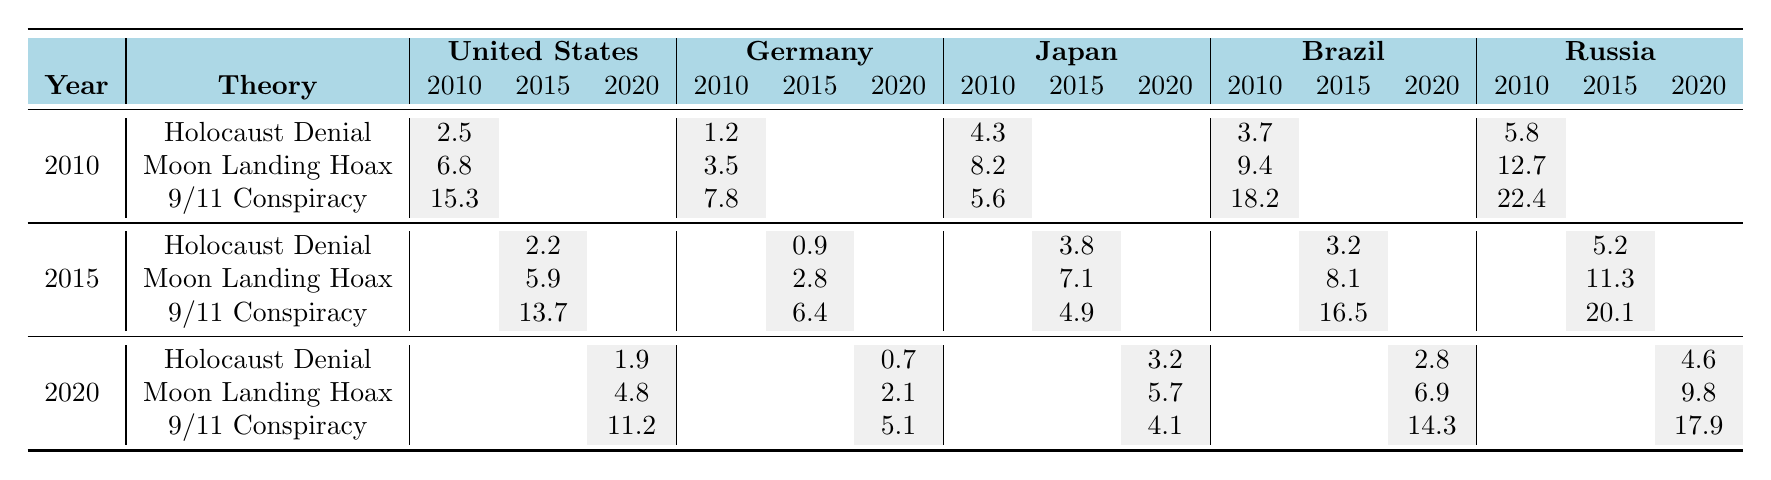What was the percentage of Holocaust denial in the United States in 2010? The table shows that the percentage for Holocaust denial in the United States for the year 2010 is 2.5.
Answer: 2.5% What country had the highest percentage of belief in the 9/11 conspiracy in 2020? According to the table, Russia had the highest percentage of belief in the 9/11 conspiracy in 2020, with a value of 17.9.
Answer: Russia What is the difference in the belief in the Moon Landing Hoax between the United States and Germany in 2015? In 2015, the United States had 5.9 and Germany had 2.8 for the Moon Landing Hoax. The difference is 5.9 - 2.8 = 3.1.
Answer: 3.1% What was the average percentage of Holocaust denial across all countries in 2020? In 2020, the percentages of Holocaust denial were: United States = 1.9, Germany = 0.7, Japan = 3.2, Brazil = 2.8, and Russia = 4.6. Summing these values gives 1.9 + 0.7 + 3.2 + 2.8 + 4.6 = 13.2. There are 5 countries, so the average is 13.2 / 5 = 2.64.
Answer: 2.64% Did the belief in the Moon Landing Hoax decrease in Brazil from 2010 to 2020? For Brazil, the percentage of belief in the Moon Landing Hoax in 2010 was 9.4, and in 2020 it was 6.9. Since 9.4 is greater than 6.9, it is true that there was a decrease.
Answer: Yes What trend can be observed for Holocaust denial in Germany from 2010 to 2020? The percentages for Holocaust denial in Germany from 2010 to 2020 are: 1.2, 0.9, and 0.7. This shows a consistent decrease over the years.
Answer: Decrease Which country had the lowest percentage of belief in the Moon Landing Hoax in 2020? Referring to the table, Japan had the lowest percentage for the Moon Landing Hoax in 2020, with a value of 5.7.
Answer: Japan What is the total percentage of belief in the 9/11 conspiracy across all countries in 2015? In 2015, the percentages of belief in the 9/11 conspiracy were: United States = 13.7, Germany = 6.4, Japan = 4.9, Brazil = 16.5, and Russia = 20.1. The total is 13.7 + 6.4 + 4.9 + 16.5 + 20.1 = 61.6.
Answer: 61.6% Is the percentage of Holocaust denial in the United States lower in 2020 compared to 2015? The percentages for Holocaust denial in the United States were: 2015 = 2.2 and 2020 = 1.9. Since 1.9 is less than 2.2, it is true that the percentage is lower.
Answer: Yes What pattern can be seen in the belief in the Moon Landing Hoax in Russia from 2010 to 2020? The percentages in Russia from 2010 to 2020 are: 12.7, 11.3, and 9.8, which indicates a steady decrease over the years.
Answer: Decrease 